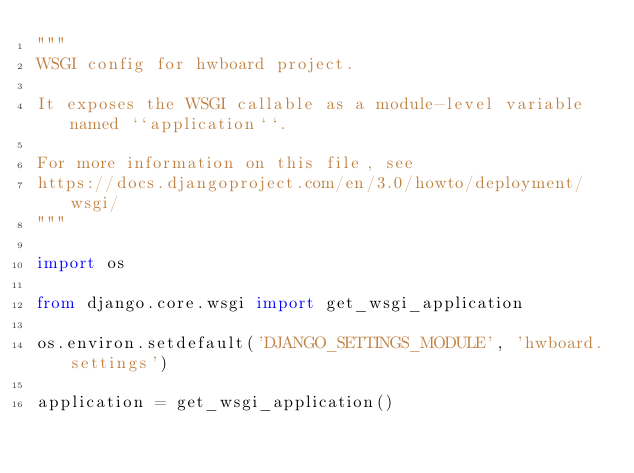<code> <loc_0><loc_0><loc_500><loc_500><_Python_>"""
WSGI config for hwboard project.

It exposes the WSGI callable as a module-level variable named ``application``.

For more information on this file, see
https://docs.djangoproject.com/en/3.0/howto/deployment/wsgi/
"""

import os

from django.core.wsgi import get_wsgi_application

os.environ.setdefault('DJANGO_SETTINGS_MODULE', 'hwboard.settings')

application = get_wsgi_application()
</code> 